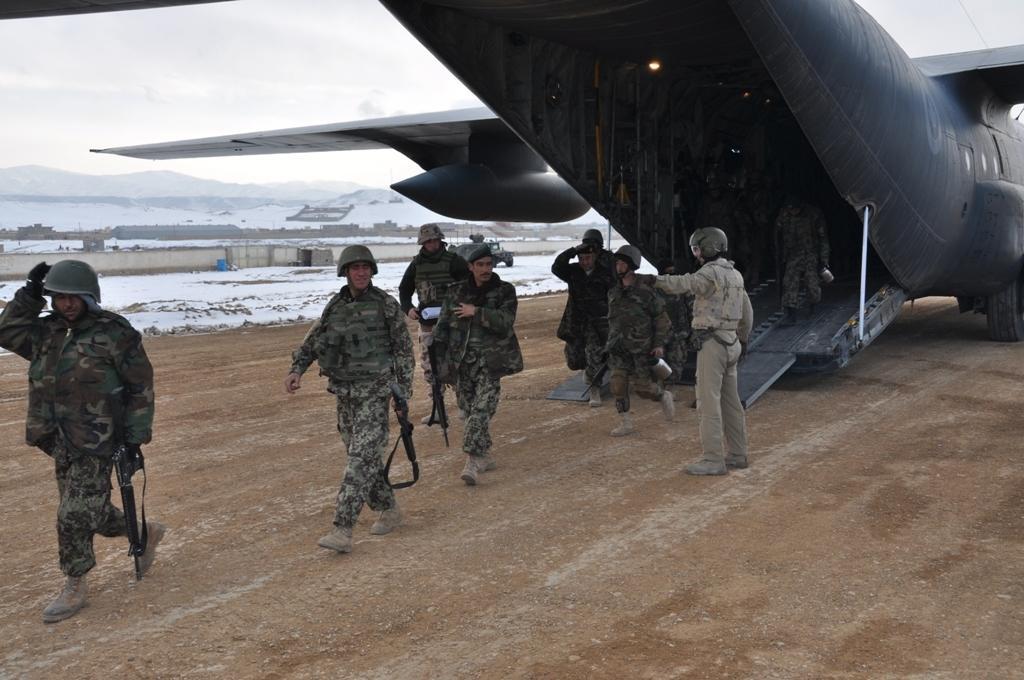How would you summarize this image in a sentence or two? As we can see in the image there are few people here and there wearing army dresses and holding guns. On the right side there is a plane. In the background there is water and on the top there is a sky. 